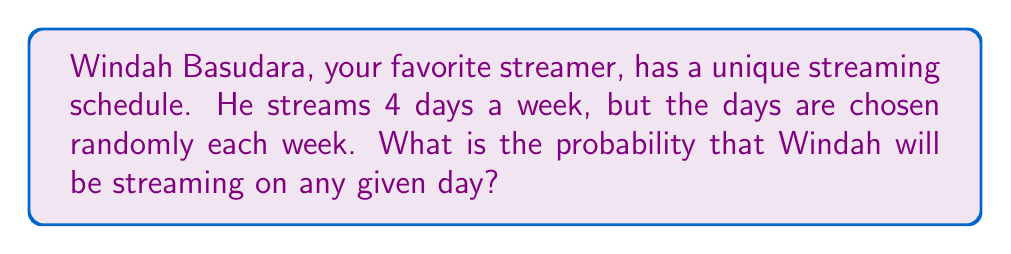Show me your answer to this math problem. Let's approach this step-by-step:

1) First, we need to identify the total number of possible outcomes. In this case, it's the number of days in a week:
   $$ \text{Total days} = 7 $$

2) Next, we need to identify the number of favorable outcomes. This is the number of days Windah streams:
   $$ \text{Streaming days} = 4 $$

3) The probability of an event is calculated by dividing the number of favorable outcomes by the total number of possible outcomes:

   $$ P(\text{streaming}) = \frac{\text{Streaming days}}{\text{Total days}} $$

4) Substituting our values:

   $$ P(\text{streaming}) = \frac{4}{7} $$

5) This fraction can be left as is, or we can convert it to a decimal:

   $$ P(\text{streaming}) = \frac{4}{7} \approx 0.5714 $$

6) To express as a percentage, we multiply by 100:

   $$ P(\text{streaming}) = \frac{4}{7} \approx 57.14\% $$

Thus, on any given day, there's a $\frac{4}{7}$ or approximately 57.14% chance that Windah Basudara will be streaming.
Answer: $\frac{4}{7}$ 